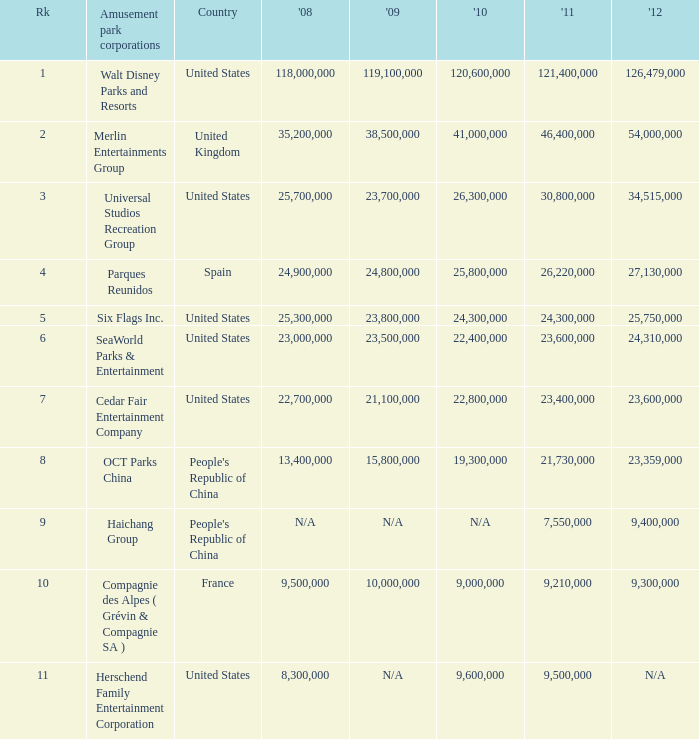Parse the table in full. {'header': ['Rk', 'Amusement park corporations', 'Country', "'08", "'09", "'10", "'11", "'12"], 'rows': [['1', 'Walt Disney Parks and Resorts', 'United States', '118,000,000', '119,100,000', '120,600,000', '121,400,000', '126,479,000'], ['2', 'Merlin Entertainments Group', 'United Kingdom', '35,200,000', '38,500,000', '41,000,000', '46,400,000', '54,000,000'], ['3', 'Universal Studios Recreation Group', 'United States', '25,700,000', '23,700,000', '26,300,000', '30,800,000', '34,515,000'], ['4', 'Parques Reunidos', 'Spain', '24,900,000', '24,800,000', '25,800,000', '26,220,000', '27,130,000'], ['5', 'Six Flags Inc.', 'United States', '25,300,000', '23,800,000', '24,300,000', '24,300,000', '25,750,000'], ['6', 'SeaWorld Parks & Entertainment', 'United States', '23,000,000', '23,500,000', '22,400,000', '23,600,000', '24,310,000'], ['7', 'Cedar Fair Entertainment Company', 'United States', '22,700,000', '21,100,000', '22,800,000', '23,400,000', '23,600,000'], ['8', 'OCT Parks China', "People's Republic of China", '13,400,000', '15,800,000', '19,300,000', '21,730,000', '23,359,000'], ['9', 'Haichang Group', "People's Republic of China", 'N/A', 'N/A', 'N/A', '7,550,000', '9,400,000'], ['10', 'Compagnie des Alpes ( Grévin & Compagnie SA )', 'France', '9,500,000', '10,000,000', '9,000,000', '9,210,000', '9,300,000'], ['11', 'Herschend Family Entertainment Corporation', 'United States', '8,300,000', 'N/A', '9,600,000', '9,500,000', 'N/A']]} What is the Rank listed for the attendance of 2010 of 9,000,000 and 2011 larger than 9,210,000? None. 